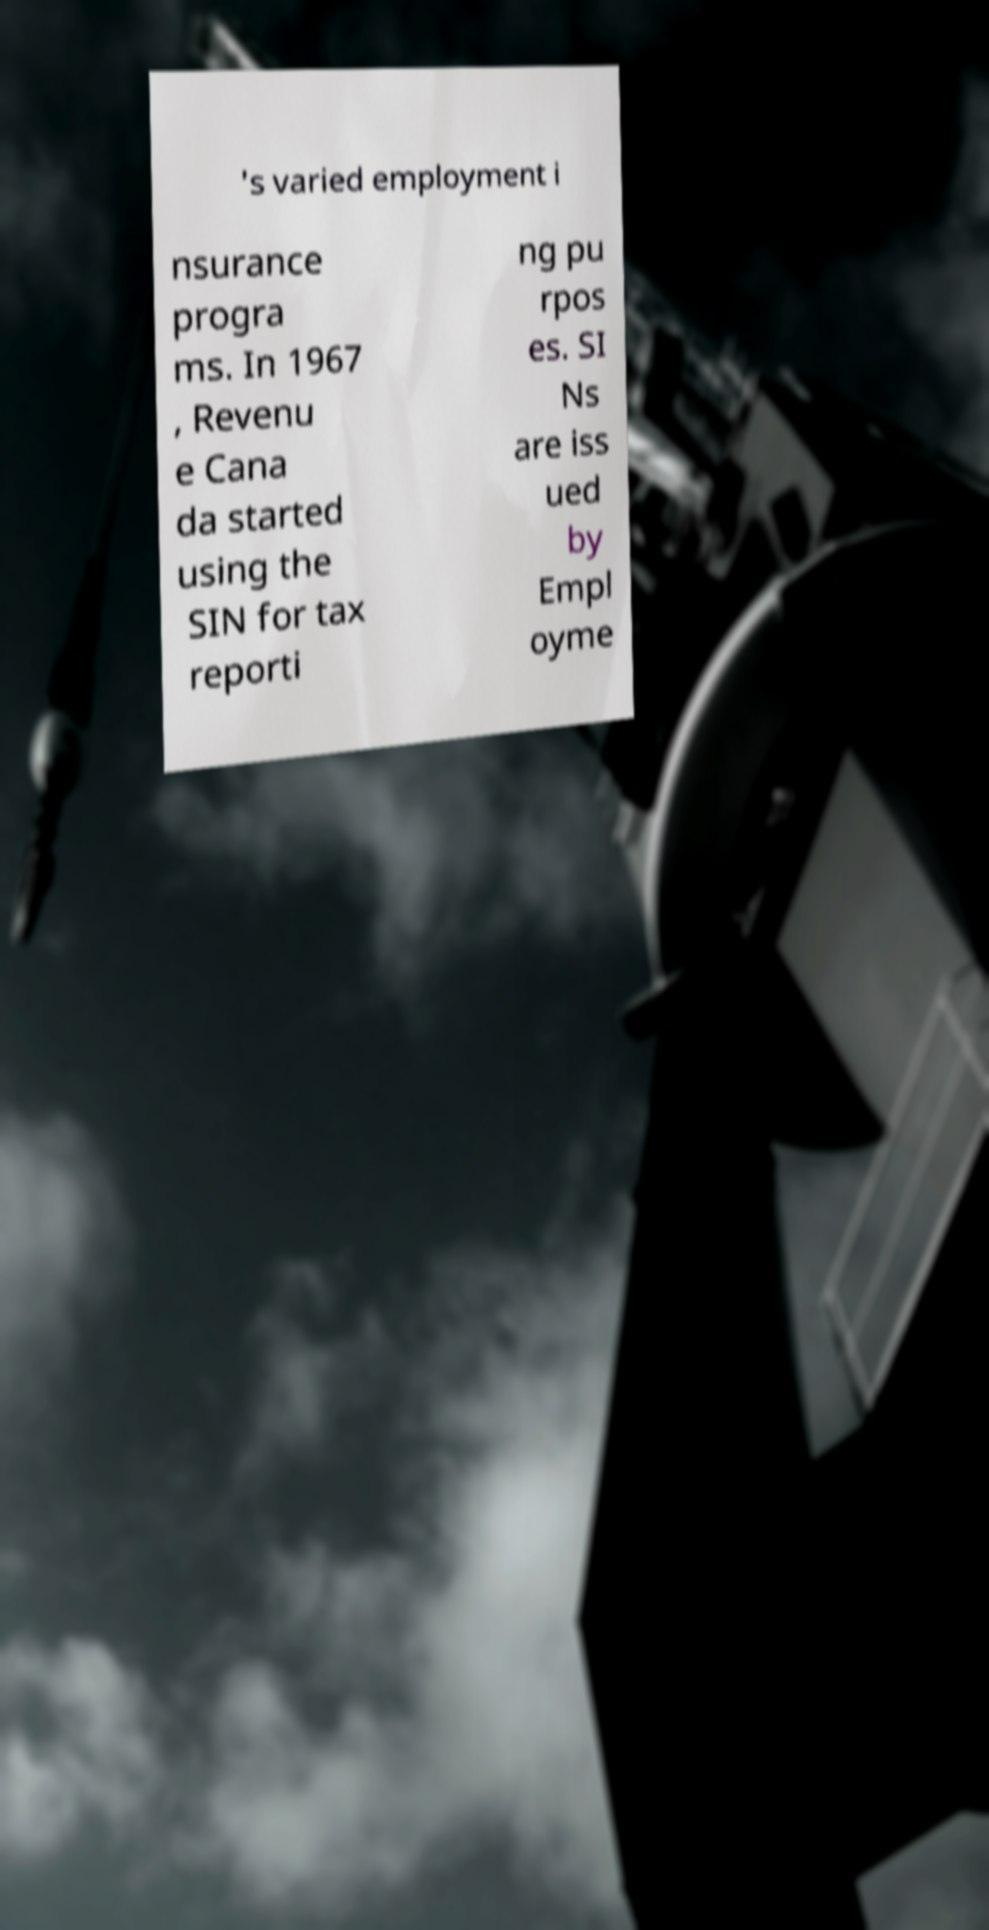Can you accurately transcribe the text from the provided image for me? 's varied employment i nsurance progra ms. In 1967 , Revenu e Cana da started using the SIN for tax reporti ng pu rpos es. SI Ns are iss ued by Empl oyme 